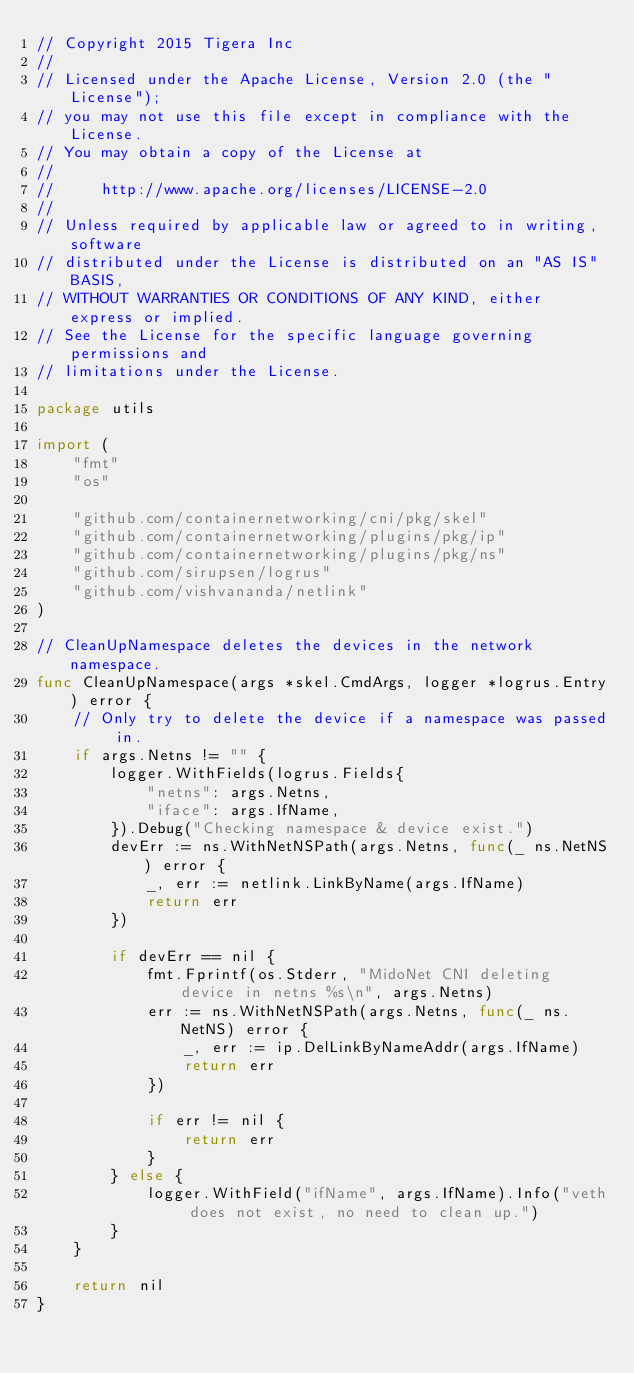Convert code to text. <code><loc_0><loc_0><loc_500><loc_500><_Go_>// Copyright 2015 Tigera Inc
//
// Licensed under the Apache License, Version 2.0 (the "License");
// you may not use this file except in compliance with the License.
// You may obtain a copy of the License at
//
//     http://www.apache.org/licenses/LICENSE-2.0
//
// Unless required by applicable law or agreed to in writing, software
// distributed under the License is distributed on an "AS IS" BASIS,
// WITHOUT WARRANTIES OR CONDITIONS OF ANY KIND, either express or implied.
// See the License for the specific language governing permissions and
// limitations under the License.

package utils

import (
	"fmt"
	"os"

	"github.com/containernetworking/cni/pkg/skel"
	"github.com/containernetworking/plugins/pkg/ip"
	"github.com/containernetworking/plugins/pkg/ns"
	"github.com/sirupsen/logrus"
	"github.com/vishvananda/netlink"
)

// CleanUpNamespace deletes the devices in the network namespace.
func CleanUpNamespace(args *skel.CmdArgs, logger *logrus.Entry) error {
	// Only try to delete the device if a namespace was passed in.
	if args.Netns != "" {
		logger.WithFields(logrus.Fields{
			"netns": args.Netns,
			"iface": args.IfName,
		}).Debug("Checking namespace & device exist.")
		devErr := ns.WithNetNSPath(args.Netns, func(_ ns.NetNS) error {
			_, err := netlink.LinkByName(args.IfName)
			return err
		})

		if devErr == nil {
			fmt.Fprintf(os.Stderr, "MidoNet CNI deleting device in netns %s\n", args.Netns)
			err := ns.WithNetNSPath(args.Netns, func(_ ns.NetNS) error {
				_, err := ip.DelLinkByNameAddr(args.IfName)
				return err
			})

			if err != nil {
				return err
			}
		} else {
			logger.WithField("ifName", args.IfName).Info("veth does not exist, no need to clean up.")
		}
	}

	return nil
}
</code> 